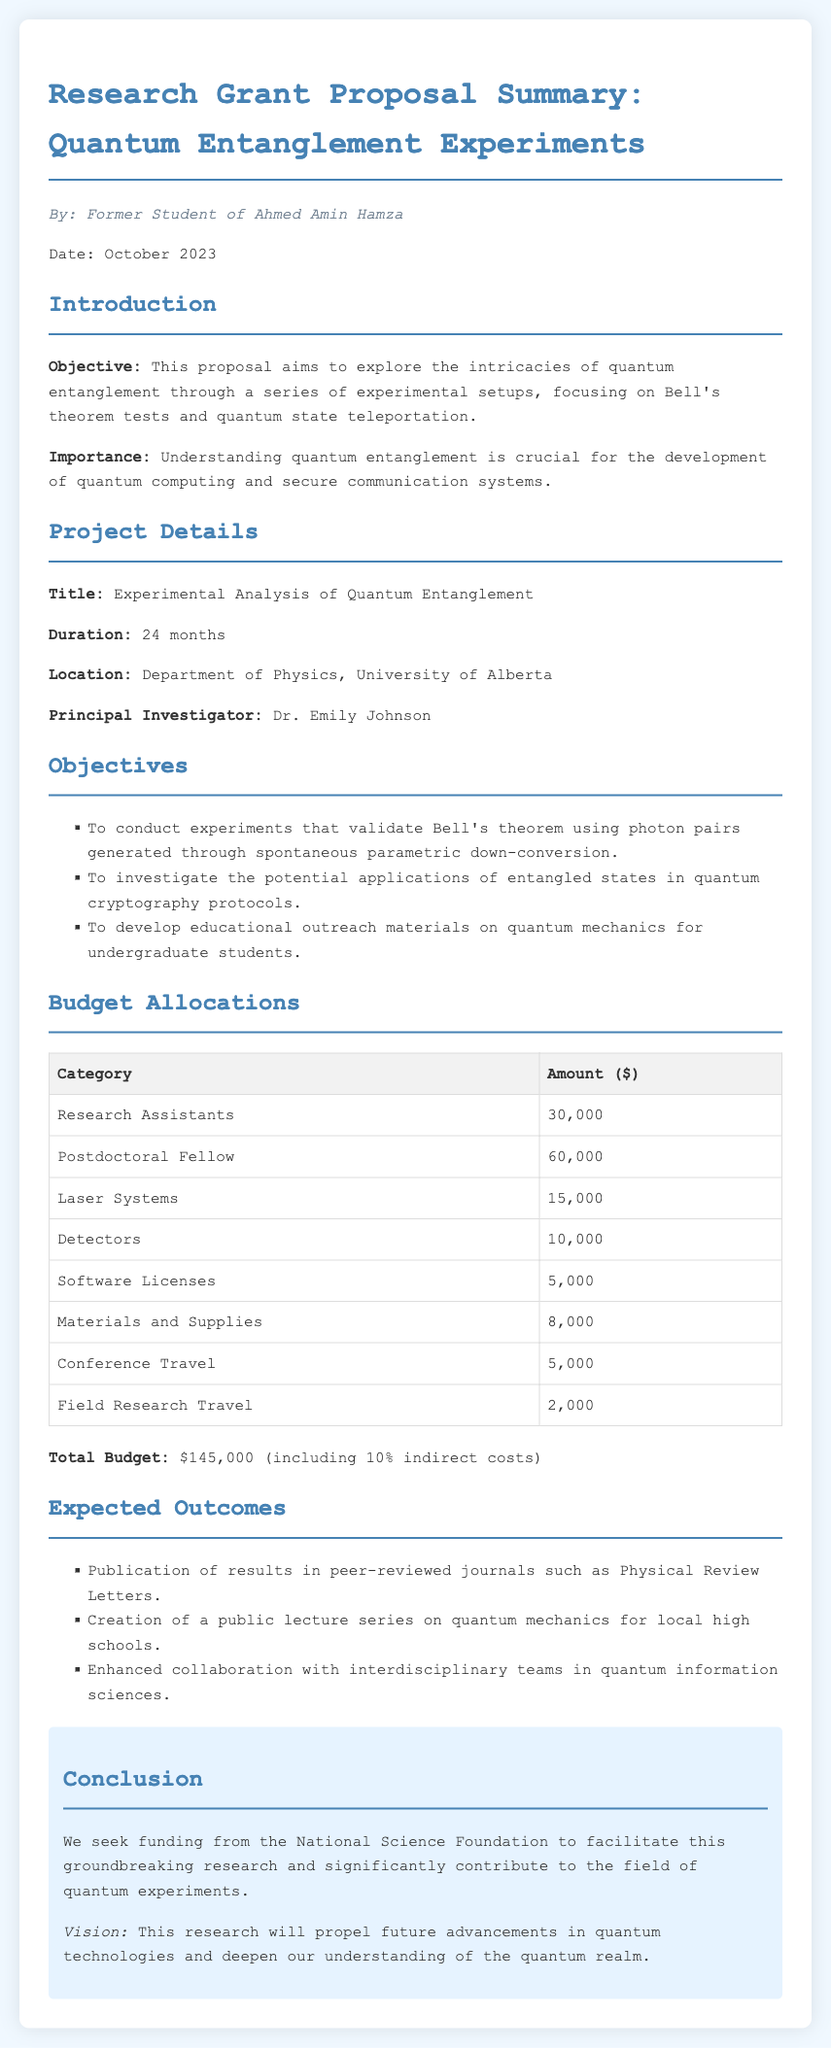What is the title of the project? The title of the project is stated in the "Project Details" section and refers to the main focus of the research proposal.
Answer: Experimental Analysis of Quantum Entanglement Who is the Principal Investigator? The name of the Principal Investigator is found in the "Project Details" section, identifying the lead researcher for the proposal.
Answer: Dr. Emily Johnson What is the total budget requested? The total budget amount can be found in the "Budget Allocations" section, summarizing the financial requirements for the project.
Answer: $145,000 What is the duration of the project? The duration is specified in the "Project Details" section, indicating the length of time allocated for completion of the research.
Answer: 24 months What is the primary objective of the research? The primary objective is defined in the "Introduction" section, summarizing the main goal of the research proposal.
Answer: To explore the intricacies of quantum entanglement What is the specific budget allocation for Laser Systems? The budget allocation for Laser Systems is detailed in the "Budget Allocations" table, providing a breakdown of expenses for each category.
Answer: 15,000 Which journal is targeted for the publication of results? The document mentions a specific journal for publication in the "Expected Outcomes" section, indicating where the research results are intended to be shared.
Answer: Physical Review Letters What percentage of indirect costs is included in the total budget? The total budget includes a certain percentage for indirect costs as indicated in the "Budget Allocations" section, which is part of the financial overview.
Answer: 10% 